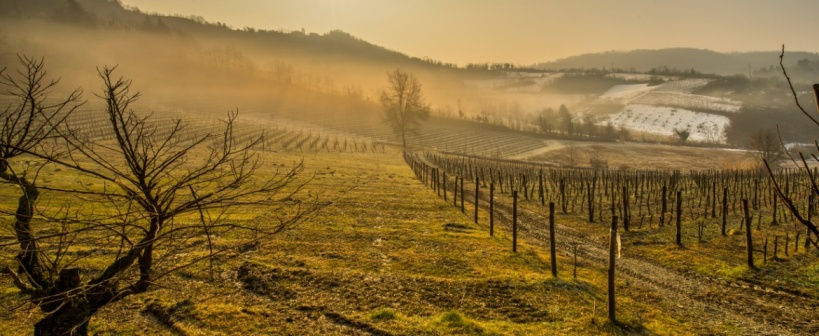What might be the ecological impact of this vineyard on its surrounding environment? Vineyards like the one pictured can have a significant impact on their local ecosystem. The management of soil and water resources, the use of pesticides and fertilizers, and the biodiversity within and around the vineyard all play crucial roles. Properly managed, vineyards can support a variety of flora and fauna, while unsustainable practices might lead to soil degradation and biodiversity loss. This particular vineyard, with its extensive cover of vegetation, might help in preventing soil erosion and could be part of a broader environmental stewardship strategy. 